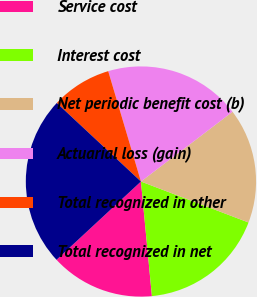Convert chart. <chart><loc_0><loc_0><loc_500><loc_500><pie_chart><fcel>Service cost<fcel>Interest cost<fcel>Net periodic benefit cost (b)<fcel>Actuarial loss (gain)<fcel>Total recognized in other<fcel>Total recognized in net<nl><fcel>14.62%<fcel>17.69%<fcel>16.15%<fcel>19.23%<fcel>8.46%<fcel>23.85%<nl></chart> 